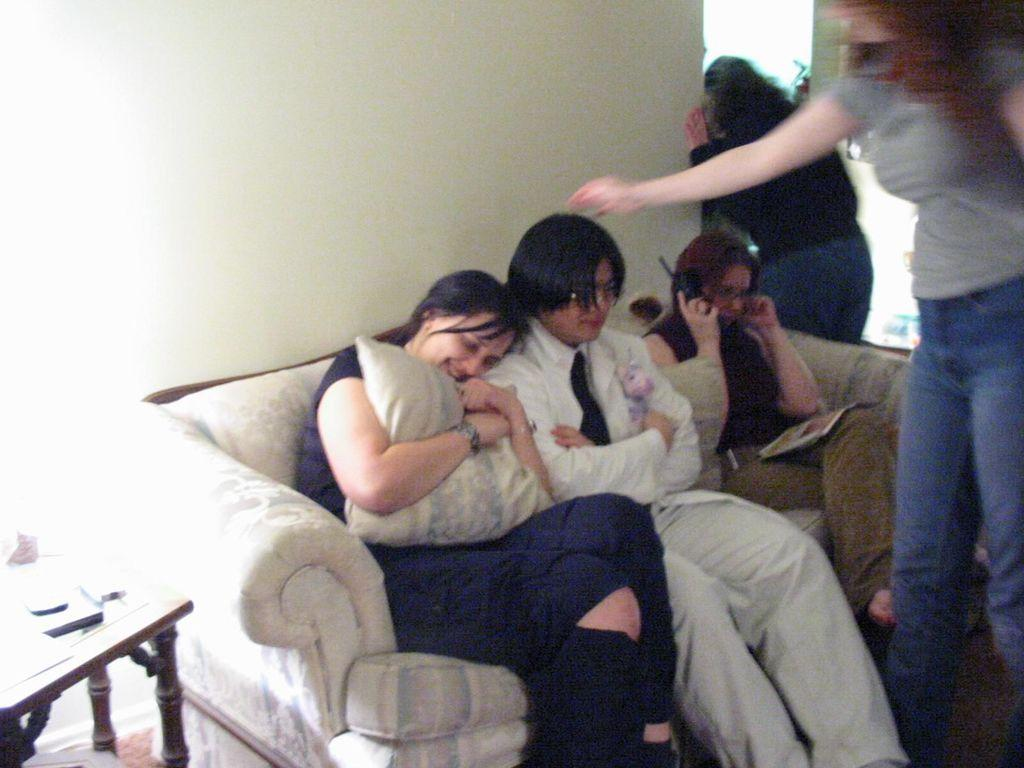How many people are sitting on the sofa in the image? There are three people sitting on a sofa in the image. How many people are standing in the image? There are two people standing in the image. What type of furniture is present in the image? There is a sofa and a table in the image. What can be seen on the table in the image? There is a book on the table in the image. What is on the wall in the image? There is a wall in the image, but no specific details about what is on the wall are provided. What other items are present in the image? There are pillows and some unspecified objects in the image. What type of jewel is the donkey wearing in the image? There is no donkey or jewel present in the image. What type of judgment is the judge making in the image? There is no judge or judgment being made in the image. 